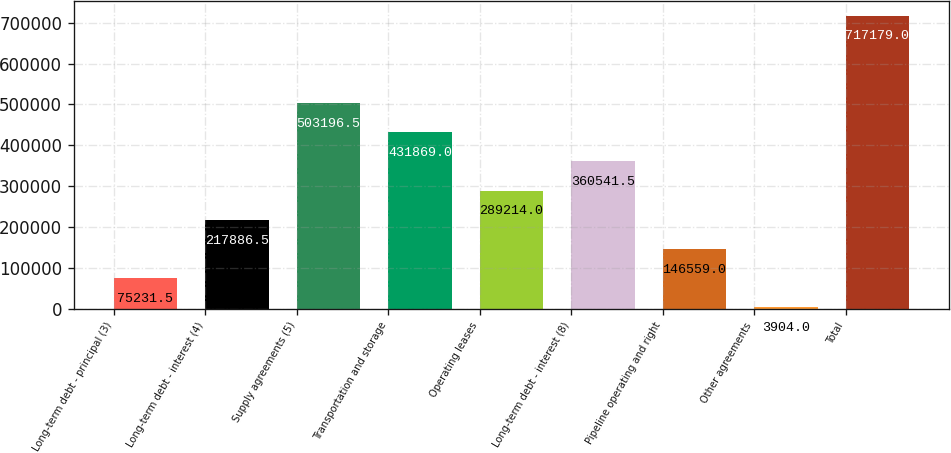Convert chart to OTSL. <chart><loc_0><loc_0><loc_500><loc_500><bar_chart><fcel>Long-term debt - principal (3)<fcel>Long-term debt - interest (4)<fcel>Supply agreements (5)<fcel>Transportation and storage<fcel>Operating leases<fcel>Long-term debt - interest (8)<fcel>Pipeline operating and right<fcel>Other agreements<fcel>Total<nl><fcel>75231.5<fcel>217886<fcel>503196<fcel>431869<fcel>289214<fcel>360542<fcel>146559<fcel>3904<fcel>717179<nl></chart> 